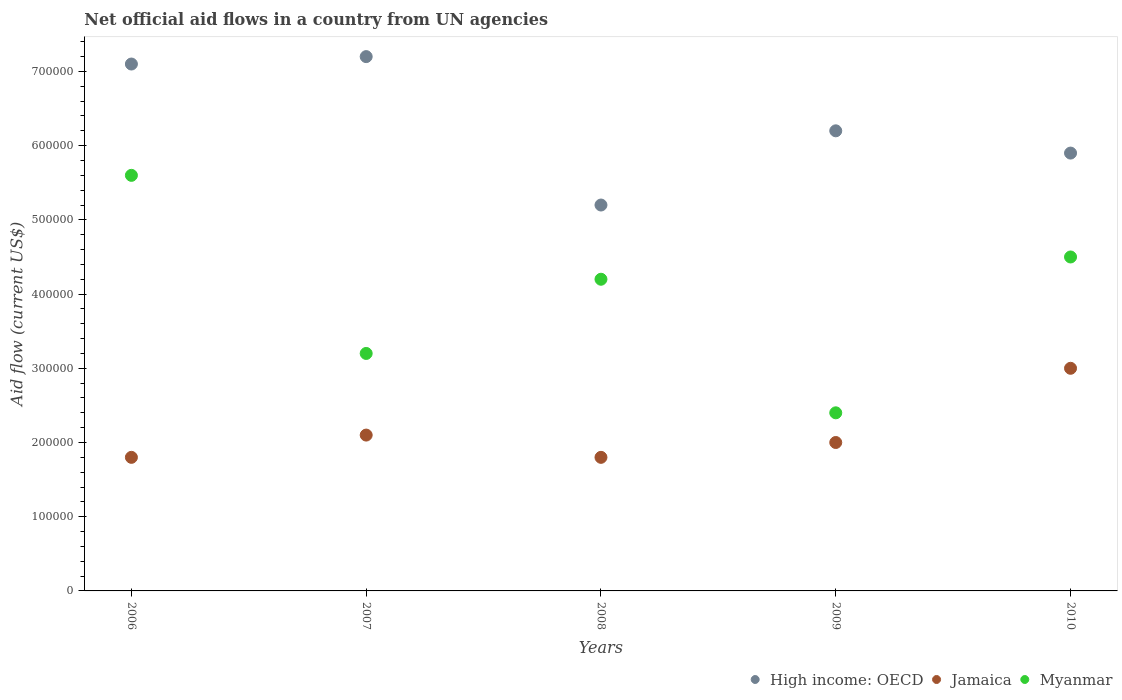Is the number of dotlines equal to the number of legend labels?
Your answer should be compact. Yes. What is the net official aid flow in Jamaica in 2010?
Ensure brevity in your answer.  3.00e+05. Across all years, what is the maximum net official aid flow in Myanmar?
Your response must be concise. 5.60e+05. Across all years, what is the minimum net official aid flow in Jamaica?
Keep it short and to the point. 1.80e+05. In which year was the net official aid flow in Myanmar maximum?
Ensure brevity in your answer.  2006. In which year was the net official aid flow in Myanmar minimum?
Provide a succinct answer. 2009. What is the total net official aid flow in Myanmar in the graph?
Offer a very short reply. 1.99e+06. What is the difference between the net official aid flow in Myanmar in 2006 and that in 2008?
Keep it short and to the point. 1.40e+05. What is the difference between the net official aid flow in High income: OECD in 2008 and the net official aid flow in Jamaica in 2010?
Offer a very short reply. 2.20e+05. What is the average net official aid flow in Myanmar per year?
Your answer should be compact. 3.98e+05. In the year 2009, what is the difference between the net official aid flow in Jamaica and net official aid flow in High income: OECD?
Your answer should be very brief. -4.20e+05. Is the net official aid flow in Jamaica in 2007 less than that in 2008?
Give a very brief answer. No. What is the difference between the highest and the second highest net official aid flow in Myanmar?
Make the answer very short. 1.10e+05. What is the difference between the highest and the lowest net official aid flow in Myanmar?
Give a very brief answer. 3.20e+05. Is the sum of the net official aid flow in Jamaica in 2008 and 2010 greater than the maximum net official aid flow in Myanmar across all years?
Provide a short and direct response. No. Is the net official aid flow in Jamaica strictly less than the net official aid flow in Myanmar over the years?
Make the answer very short. Yes. How many dotlines are there?
Your answer should be compact. 3. How many years are there in the graph?
Keep it short and to the point. 5. What is the difference between two consecutive major ticks on the Y-axis?
Keep it short and to the point. 1.00e+05. Are the values on the major ticks of Y-axis written in scientific E-notation?
Give a very brief answer. No. Does the graph contain any zero values?
Provide a succinct answer. No. Does the graph contain grids?
Ensure brevity in your answer.  No. How are the legend labels stacked?
Your answer should be compact. Horizontal. What is the title of the graph?
Your answer should be compact. Net official aid flows in a country from UN agencies. What is the label or title of the X-axis?
Your answer should be very brief. Years. What is the Aid flow (current US$) of High income: OECD in 2006?
Provide a succinct answer. 7.10e+05. What is the Aid flow (current US$) in Jamaica in 2006?
Offer a terse response. 1.80e+05. What is the Aid flow (current US$) in Myanmar in 2006?
Offer a very short reply. 5.60e+05. What is the Aid flow (current US$) of High income: OECD in 2007?
Provide a short and direct response. 7.20e+05. What is the Aid flow (current US$) in Jamaica in 2007?
Your answer should be compact. 2.10e+05. What is the Aid flow (current US$) of Myanmar in 2007?
Keep it short and to the point. 3.20e+05. What is the Aid flow (current US$) of High income: OECD in 2008?
Your response must be concise. 5.20e+05. What is the Aid flow (current US$) in Jamaica in 2008?
Provide a short and direct response. 1.80e+05. What is the Aid flow (current US$) of High income: OECD in 2009?
Give a very brief answer. 6.20e+05. What is the Aid flow (current US$) of High income: OECD in 2010?
Keep it short and to the point. 5.90e+05. What is the Aid flow (current US$) of Jamaica in 2010?
Your response must be concise. 3.00e+05. Across all years, what is the maximum Aid flow (current US$) of High income: OECD?
Your response must be concise. 7.20e+05. Across all years, what is the maximum Aid flow (current US$) in Jamaica?
Make the answer very short. 3.00e+05. Across all years, what is the maximum Aid flow (current US$) of Myanmar?
Ensure brevity in your answer.  5.60e+05. Across all years, what is the minimum Aid flow (current US$) in High income: OECD?
Your response must be concise. 5.20e+05. Across all years, what is the minimum Aid flow (current US$) in Myanmar?
Offer a very short reply. 2.40e+05. What is the total Aid flow (current US$) of High income: OECD in the graph?
Offer a very short reply. 3.16e+06. What is the total Aid flow (current US$) of Jamaica in the graph?
Your answer should be compact. 1.07e+06. What is the total Aid flow (current US$) in Myanmar in the graph?
Your answer should be very brief. 1.99e+06. What is the difference between the Aid flow (current US$) in Jamaica in 2006 and that in 2007?
Give a very brief answer. -3.00e+04. What is the difference between the Aid flow (current US$) of Myanmar in 2006 and that in 2007?
Your answer should be very brief. 2.40e+05. What is the difference between the Aid flow (current US$) in Jamaica in 2006 and that in 2008?
Ensure brevity in your answer.  0. What is the difference between the Aid flow (current US$) in Myanmar in 2006 and that in 2009?
Provide a short and direct response. 3.20e+05. What is the difference between the Aid flow (current US$) of Jamaica in 2006 and that in 2010?
Make the answer very short. -1.20e+05. What is the difference between the Aid flow (current US$) of Jamaica in 2007 and that in 2008?
Provide a short and direct response. 3.00e+04. What is the difference between the Aid flow (current US$) in Jamaica in 2007 and that in 2009?
Make the answer very short. 10000. What is the difference between the Aid flow (current US$) in Myanmar in 2007 and that in 2009?
Give a very brief answer. 8.00e+04. What is the difference between the Aid flow (current US$) in High income: OECD in 2007 and that in 2010?
Offer a terse response. 1.30e+05. What is the difference between the Aid flow (current US$) in Myanmar in 2007 and that in 2010?
Provide a short and direct response. -1.30e+05. What is the difference between the Aid flow (current US$) in High income: OECD in 2008 and that in 2009?
Ensure brevity in your answer.  -1.00e+05. What is the difference between the Aid flow (current US$) in Jamaica in 2008 and that in 2009?
Make the answer very short. -2.00e+04. What is the difference between the Aid flow (current US$) in Myanmar in 2008 and that in 2009?
Provide a succinct answer. 1.80e+05. What is the difference between the Aid flow (current US$) of High income: OECD in 2008 and that in 2010?
Ensure brevity in your answer.  -7.00e+04. What is the difference between the Aid flow (current US$) in Jamaica in 2008 and that in 2010?
Provide a succinct answer. -1.20e+05. What is the difference between the Aid flow (current US$) of High income: OECD in 2009 and that in 2010?
Ensure brevity in your answer.  3.00e+04. What is the difference between the Aid flow (current US$) in Myanmar in 2009 and that in 2010?
Offer a terse response. -2.10e+05. What is the difference between the Aid flow (current US$) of High income: OECD in 2006 and the Aid flow (current US$) of Myanmar in 2007?
Ensure brevity in your answer.  3.90e+05. What is the difference between the Aid flow (current US$) in Jamaica in 2006 and the Aid flow (current US$) in Myanmar in 2007?
Provide a succinct answer. -1.40e+05. What is the difference between the Aid flow (current US$) of High income: OECD in 2006 and the Aid flow (current US$) of Jamaica in 2008?
Provide a succinct answer. 5.30e+05. What is the difference between the Aid flow (current US$) of Jamaica in 2006 and the Aid flow (current US$) of Myanmar in 2008?
Offer a terse response. -2.40e+05. What is the difference between the Aid flow (current US$) of High income: OECD in 2006 and the Aid flow (current US$) of Jamaica in 2009?
Your answer should be compact. 5.10e+05. What is the difference between the Aid flow (current US$) in High income: OECD in 2006 and the Aid flow (current US$) in Myanmar in 2009?
Offer a very short reply. 4.70e+05. What is the difference between the Aid flow (current US$) in Jamaica in 2006 and the Aid flow (current US$) in Myanmar in 2009?
Your answer should be very brief. -6.00e+04. What is the difference between the Aid flow (current US$) of High income: OECD in 2006 and the Aid flow (current US$) of Myanmar in 2010?
Make the answer very short. 2.60e+05. What is the difference between the Aid flow (current US$) in High income: OECD in 2007 and the Aid flow (current US$) in Jamaica in 2008?
Offer a terse response. 5.40e+05. What is the difference between the Aid flow (current US$) of High income: OECD in 2007 and the Aid flow (current US$) of Myanmar in 2008?
Provide a succinct answer. 3.00e+05. What is the difference between the Aid flow (current US$) of Jamaica in 2007 and the Aid flow (current US$) of Myanmar in 2008?
Your answer should be very brief. -2.10e+05. What is the difference between the Aid flow (current US$) of High income: OECD in 2007 and the Aid flow (current US$) of Jamaica in 2009?
Your response must be concise. 5.20e+05. What is the difference between the Aid flow (current US$) in High income: OECD in 2007 and the Aid flow (current US$) in Myanmar in 2009?
Your answer should be very brief. 4.80e+05. What is the difference between the Aid flow (current US$) in Jamaica in 2007 and the Aid flow (current US$) in Myanmar in 2010?
Give a very brief answer. -2.40e+05. What is the difference between the Aid flow (current US$) in High income: OECD in 2008 and the Aid flow (current US$) in Jamaica in 2009?
Ensure brevity in your answer.  3.20e+05. What is the difference between the Aid flow (current US$) of High income: OECD in 2008 and the Aid flow (current US$) of Jamaica in 2010?
Offer a very short reply. 2.20e+05. What is the difference between the Aid flow (current US$) of Jamaica in 2008 and the Aid flow (current US$) of Myanmar in 2010?
Your response must be concise. -2.70e+05. What is the difference between the Aid flow (current US$) in Jamaica in 2009 and the Aid flow (current US$) in Myanmar in 2010?
Provide a succinct answer. -2.50e+05. What is the average Aid flow (current US$) of High income: OECD per year?
Keep it short and to the point. 6.32e+05. What is the average Aid flow (current US$) of Jamaica per year?
Your response must be concise. 2.14e+05. What is the average Aid flow (current US$) in Myanmar per year?
Your answer should be very brief. 3.98e+05. In the year 2006, what is the difference between the Aid flow (current US$) of High income: OECD and Aid flow (current US$) of Jamaica?
Your response must be concise. 5.30e+05. In the year 2006, what is the difference between the Aid flow (current US$) of High income: OECD and Aid flow (current US$) of Myanmar?
Provide a short and direct response. 1.50e+05. In the year 2006, what is the difference between the Aid flow (current US$) of Jamaica and Aid flow (current US$) of Myanmar?
Offer a terse response. -3.80e+05. In the year 2007, what is the difference between the Aid flow (current US$) of High income: OECD and Aid flow (current US$) of Jamaica?
Give a very brief answer. 5.10e+05. In the year 2007, what is the difference between the Aid flow (current US$) in High income: OECD and Aid flow (current US$) in Myanmar?
Ensure brevity in your answer.  4.00e+05. In the year 2008, what is the difference between the Aid flow (current US$) of High income: OECD and Aid flow (current US$) of Myanmar?
Provide a succinct answer. 1.00e+05. In the year 2009, what is the difference between the Aid flow (current US$) in High income: OECD and Aid flow (current US$) in Jamaica?
Keep it short and to the point. 4.20e+05. In the year 2010, what is the difference between the Aid flow (current US$) of High income: OECD and Aid flow (current US$) of Jamaica?
Ensure brevity in your answer.  2.90e+05. In the year 2010, what is the difference between the Aid flow (current US$) of High income: OECD and Aid flow (current US$) of Myanmar?
Ensure brevity in your answer.  1.40e+05. In the year 2010, what is the difference between the Aid flow (current US$) of Jamaica and Aid flow (current US$) of Myanmar?
Offer a terse response. -1.50e+05. What is the ratio of the Aid flow (current US$) of High income: OECD in 2006 to that in 2007?
Ensure brevity in your answer.  0.99. What is the ratio of the Aid flow (current US$) of Jamaica in 2006 to that in 2007?
Provide a succinct answer. 0.86. What is the ratio of the Aid flow (current US$) in High income: OECD in 2006 to that in 2008?
Offer a terse response. 1.37. What is the ratio of the Aid flow (current US$) in High income: OECD in 2006 to that in 2009?
Keep it short and to the point. 1.15. What is the ratio of the Aid flow (current US$) of Jamaica in 2006 to that in 2009?
Provide a succinct answer. 0.9. What is the ratio of the Aid flow (current US$) of Myanmar in 2006 to that in 2009?
Give a very brief answer. 2.33. What is the ratio of the Aid flow (current US$) in High income: OECD in 2006 to that in 2010?
Offer a very short reply. 1.2. What is the ratio of the Aid flow (current US$) of Myanmar in 2006 to that in 2010?
Give a very brief answer. 1.24. What is the ratio of the Aid flow (current US$) in High income: OECD in 2007 to that in 2008?
Your answer should be compact. 1.38. What is the ratio of the Aid flow (current US$) of Myanmar in 2007 to that in 2008?
Your answer should be very brief. 0.76. What is the ratio of the Aid flow (current US$) of High income: OECD in 2007 to that in 2009?
Ensure brevity in your answer.  1.16. What is the ratio of the Aid flow (current US$) of High income: OECD in 2007 to that in 2010?
Offer a terse response. 1.22. What is the ratio of the Aid flow (current US$) of Jamaica in 2007 to that in 2010?
Offer a very short reply. 0.7. What is the ratio of the Aid flow (current US$) of Myanmar in 2007 to that in 2010?
Keep it short and to the point. 0.71. What is the ratio of the Aid flow (current US$) of High income: OECD in 2008 to that in 2009?
Keep it short and to the point. 0.84. What is the ratio of the Aid flow (current US$) in Jamaica in 2008 to that in 2009?
Provide a short and direct response. 0.9. What is the ratio of the Aid flow (current US$) of High income: OECD in 2008 to that in 2010?
Offer a terse response. 0.88. What is the ratio of the Aid flow (current US$) of Myanmar in 2008 to that in 2010?
Offer a terse response. 0.93. What is the ratio of the Aid flow (current US$) in High income: OECD in 2009 to that in 2010?
Offer a terse response. 1.05. What is the ratio of the Aid flow (current US$) of Myanmar in 2009 to that in 2010?
Ensure brevity in your answer.  0.53. What is the difference between the highest and the second highest Aid flow (current US$) in Myanmar?
Make the answer very short. 1.10e+05. What is the difference between the highest and the lowest Aid flow (current US$) of High income: OECD?
Provide a succinct answer. 2.00e+05. What is the difference between the highest and the lowest Aid flow (current US$) of Myanmar?
Give a very brief answer. 3.20e+05. 